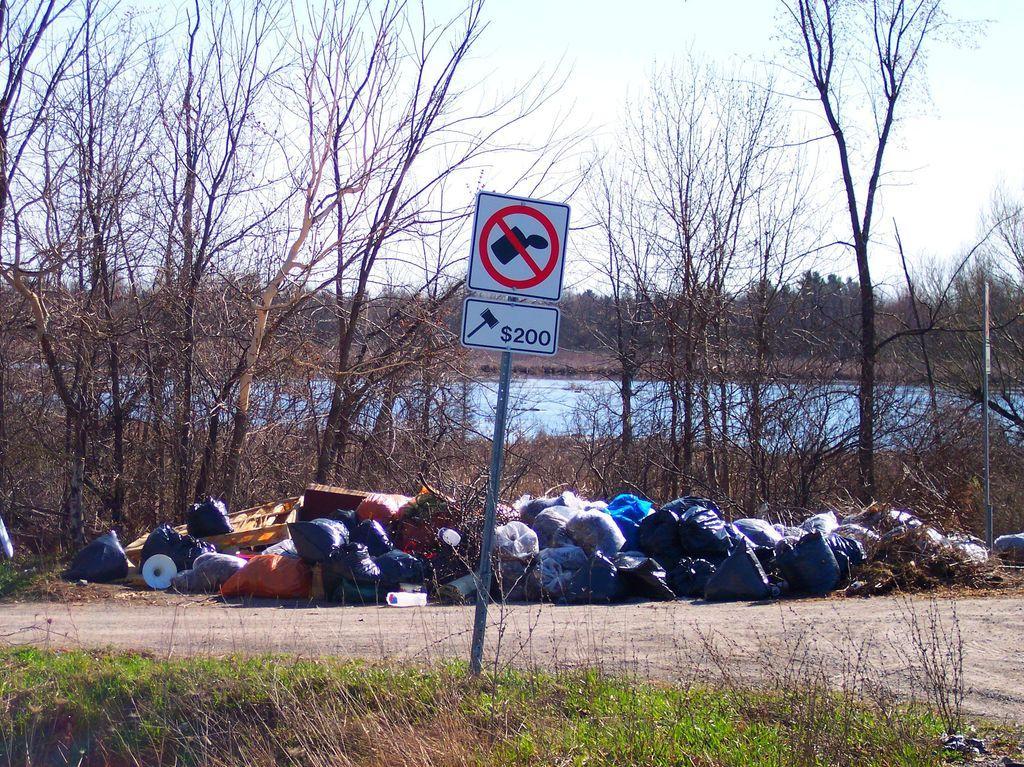In one or two sentences, can you explain what this image depicts? This image is taken outdoors. At the bottom of the image there is a ground with grass on it. At the top of the image there is a sky with clouds. In the middle of the image there is a signboard and there is garbage on the ground packed in the covers. In the background there are many trees and plants and there is a pond with water. 